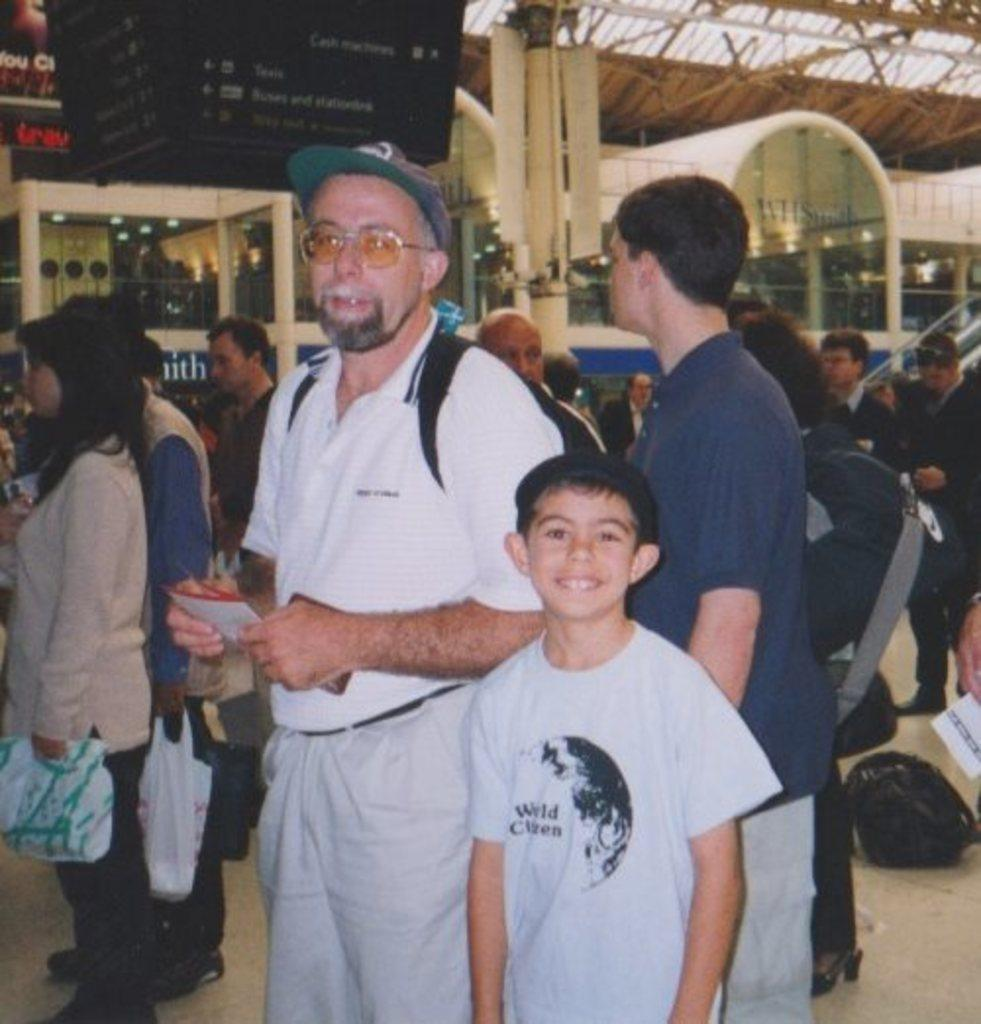How many people are in the image? There are people in the image, but the exact number is not specified. What are some people doing in the image? Some people are holding objects in the image. What type of structure can be seen in the image? There is a building in the image. What is the object that resembles a board with text? There is an object that looks like a board with text in the image. What type of fruit is being used to create a smile on the board with text? There is no fruit or smile present on the board with text in the image. 